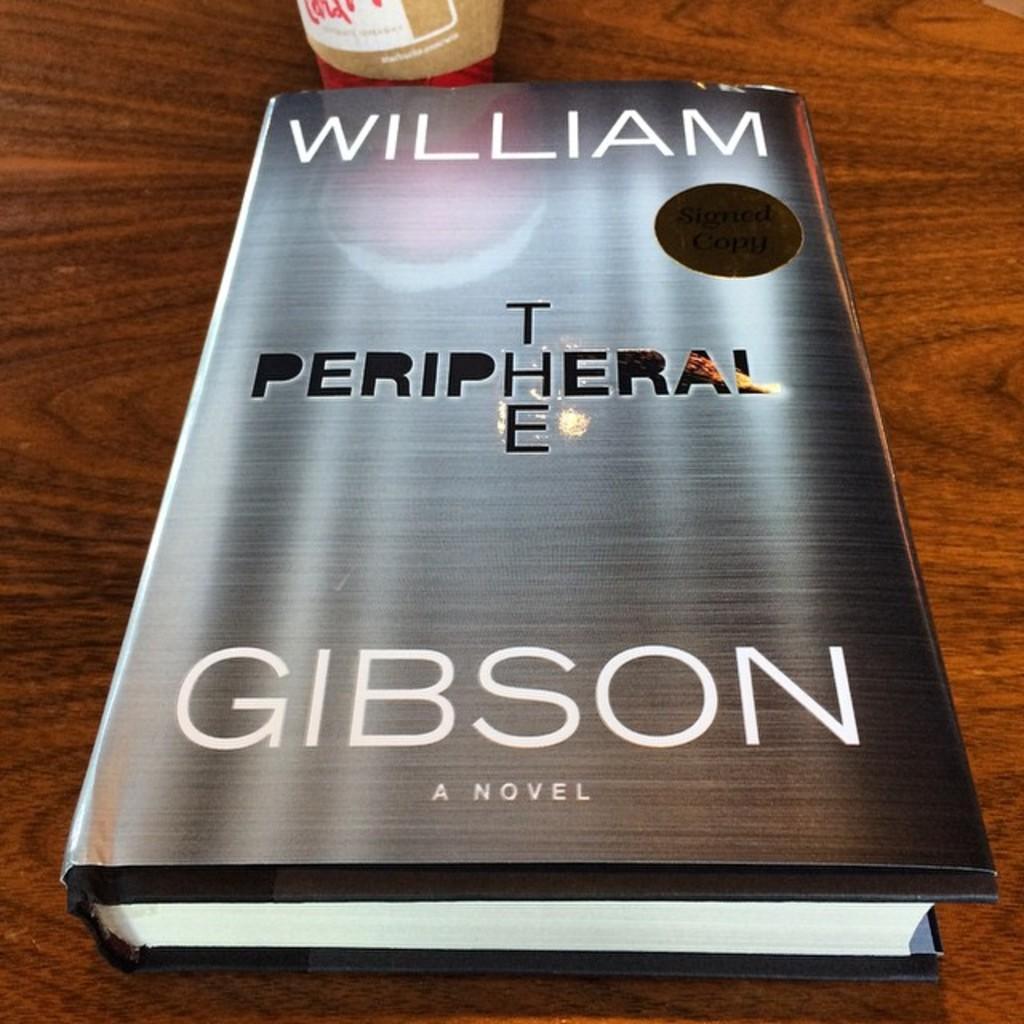Describe this image in one or two sentences. In the middle of this image, there is a book having a poster on its cover. On its poster, there are white and black color texts. This book is on a wooden table. Besides this book, there is another object. 